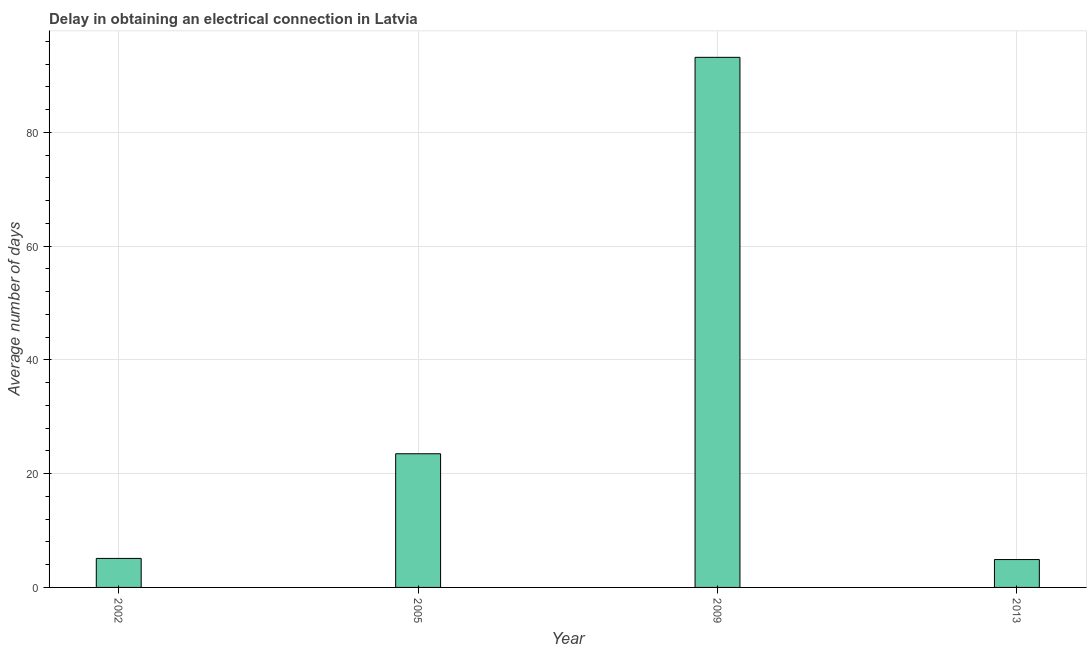What is the title of the graph?
Offer a terse response. Delay in obtaining an electrical connection in Latvia. What is the label or title of the X-axis?
Ensure brevity in your answer.  Year. What is the label or title of the Y-axis?
Offer a terse response. Average number of days. What is the dalay in electrical connection in 2009?
Offer a terse response. 93.2. Across all years, what is the maximum dalay in electrical connection?
Provide a short and direct response. 93.2. In which year was the dalay in electrical connection maximum?
Your response must be concise. 2009. In which year was the dalay in electrical connection minimum?
Provide a short and direct response. 2013. What is the sum of the dalay in electrical connection?
Make the answer very short. 126.7. What is the difference between the dalay in electrical connection in 2005 and 2009?
Provide a short and direct response. -69.7. What is the average dalay in electrical connection per year?
Offer a very short reply. 31.68. In how many years, is the dalay in electrical connection greater than 28 days?
Your answer should be very brief. 1. Do a majority of the years between 2009 and 2013 (inclusive) have dalay in electrical connection greater than 64 days?
Give a very brief answer. No. What is the ratio of the dalay in electrical connection in 2005 to that in 2013?
Your response must be concise. 4.8. Is the dalay in electrical connection in 2005 less than that in 2013?
Your response must be concise. No. What is the difference between the highest and the second highest dalay in electrical connection?
Offer a terse response. 69.7. What is the difference between the highest and the lowest dalay in electrical connection?
Offer a very short reply. 88.3. In how many years, is the dalay in electrical connection greater than the average dalay in electrical connection taken over all years?
Provide a succinct answer. 1. How many years are there in the graph?
Ensure brevity in your answer.  4. What is the difference between two consecutive major ticks on the Y-axis?
Give a very brief answer. 20. Are the values on the major ticks of Y-axis written in scientific E-notation?
Your response must be concise. No. What is the Average number of days of 2002?
Your answer should be very brief. 5.1. What is the Average number of days in 2005?
Your answer should be very brief. 23.5. What is the Average number of days in 2009?
Provide a succinct answer. 93.2. What is the Average number of days of 2013?
Your answer should be compact. 4.9. What is the difference between the Average number of days in 2002 and 2005?
Your answer should be very brief. -18.4. What is the difference between the Average number of days in 2002 and 2009?
Give a very brief answer. -88.1. What is the difference between the Average number of days in 2005 and 2009?
Make the answer very short. -69.7. What is the difference between the Average number of days in 2009 and 2013?
Offer a very short reply. 88.3. What is the ratio of the Average number of days in 2002 to that in 2005?
Offer a very short reply. 0.22. What is the ratio of the Average number of days in 2002 to that in 2009?
Keep it short and to the point. 0.06. What is the ratio of the Average number of days in 2002 to that in 2013?
Offer a terse response. 1.04. What is the ratio of the Average number of days in 2005 to that in 2009?
Provide a succinct answer. 0.25. What is the ratio of the Average number of days in 2005 to that in 2013?
Offer a very short reply. 4.8. What is the ratio of the Average number of days in 2009 to that in 2013?
Offer a very short reply. 19.02. 